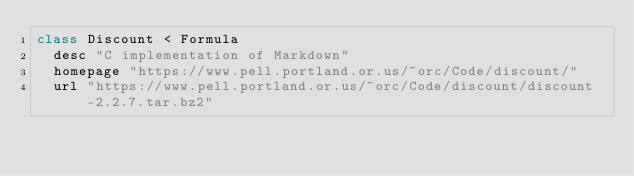<code> <loc_0><loc_0><loc_500><loc_500><_Ruby_>class Discount < Formula
  desc "C implementation of Markdown"
  homepage "https://www.pell.portland.or.us/~orc/Code/discount/"
  url "https://www.pell.portland.or.us/~orc/Code/discount/discount-2.2.7.tar.bz2"</code> 